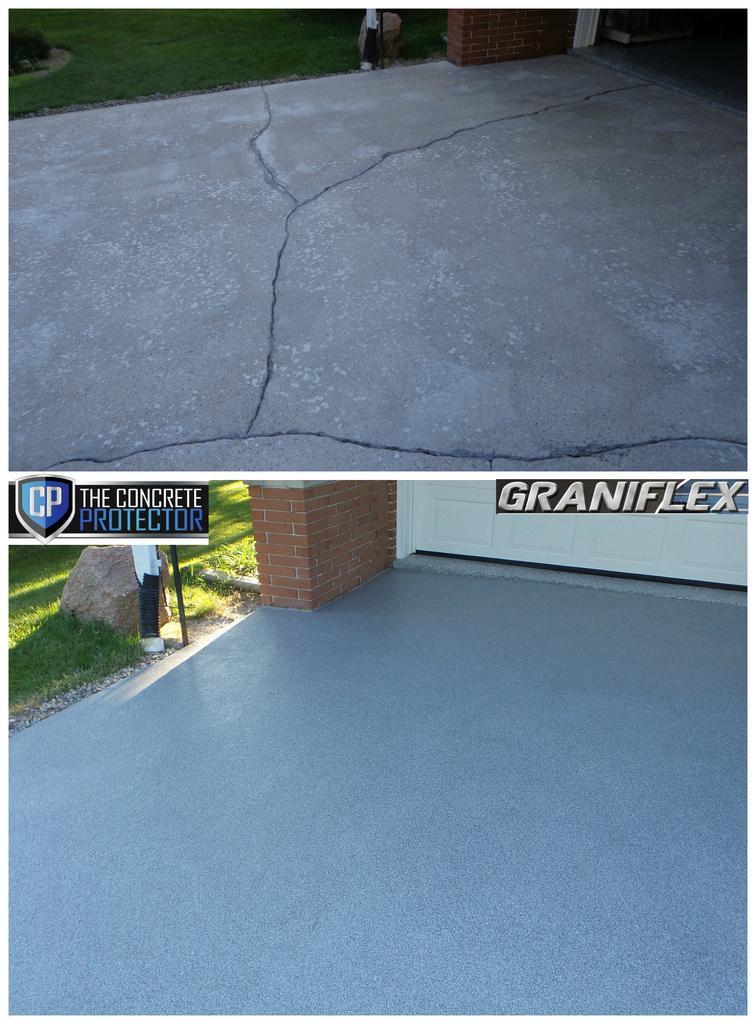Please provide a concise description of this image. Here this is a collage image, in which we can see the floor in both the images and we can see some part of ground is covered with grass. 